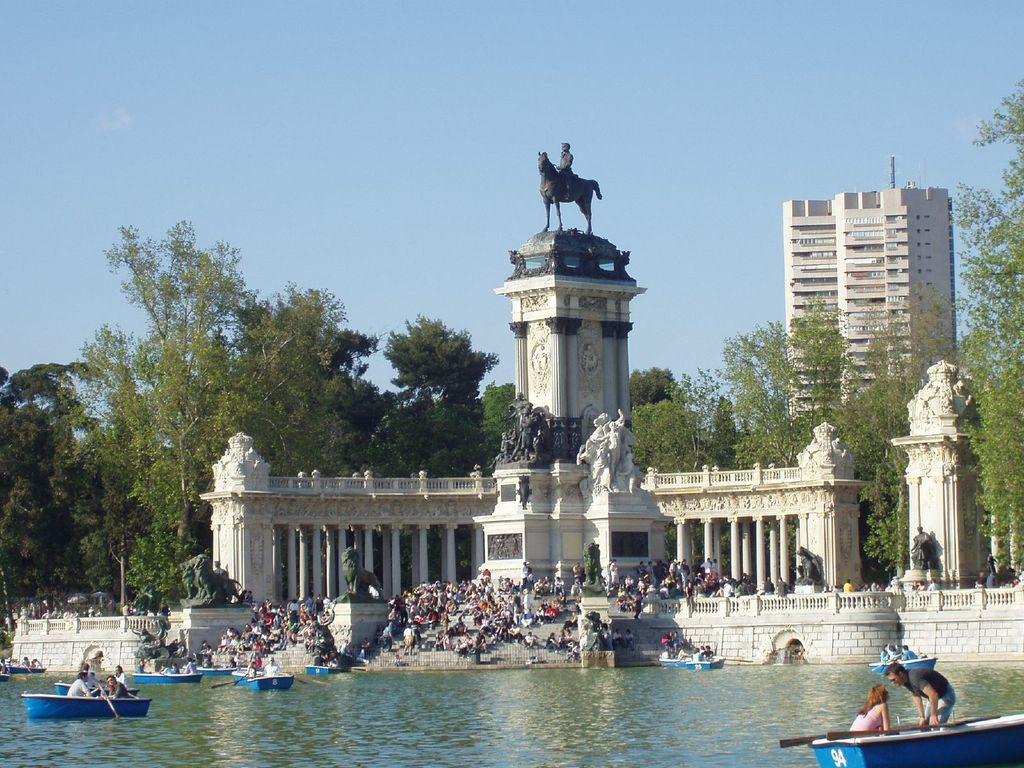Can you describe this image briefly? In this picture I can see boats on the water, there are group of people, sculptures, pillars, trees, there is a building, and in the background there is sky. 